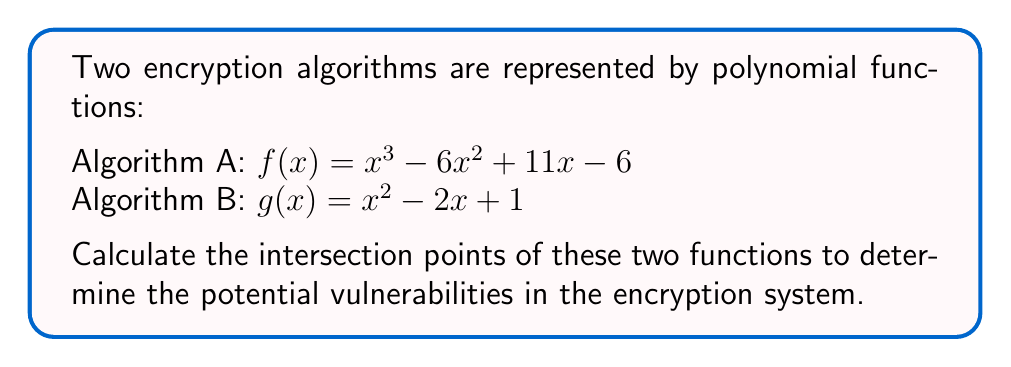Show me your answer to this math problem. To find the intersection points, we need to solve the equation $f(x) = g(x)$:

1) Set up the equation:
   $x^3 - 6x^2 + 11x - 6 = x^2 - 2x + 1$

2) Rearrange to standard form:
   $x^3 - 7x^2 + 13x - 7 = 0$

3) This is a cubic equation. Let's try to factor it:
   $(x - 1)(x^2 - 6x + 7) = 0$

4) Solve each factor:
   $x - 1 = 0$ or $x^2 - 6x + 7 = 0$
   
   $x = 1$ or use quadratic formula for $x^2 - 6x + 7 = 0$

5) Quadratic formula: $x = \frac{-b \pm \sqrt{b^2 - 4ac}}{2a}$
   
   $x = \frac{6 \pm \sqrt{36 - 28}}{2} = \frac{6 \pm \sqrt{8}}{2} = \frac{6 \pm 2\sqrt{2}}{2}$

6) Simplify:
   $x = 3 \pm \sqrt{2}$

Therefore, the intersection points are at $x = 1$, $x = 3 + \sqrt{2}$, and $x = 3 - \sqrt{2}$.
Answer: $(1, 0)$, $(3 + \sqrt{2}, 7 + 4\sqrt{2})$, $(3 - \sqrt{2}, 7 - 4\sqrt{2})$ 